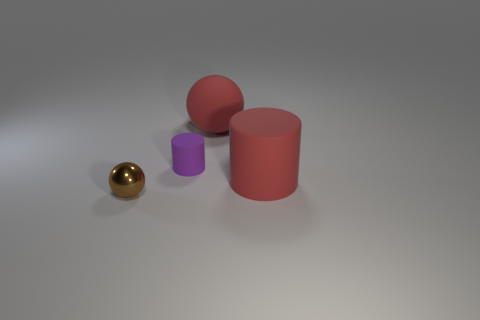Is the material of the red thing in front of the purple object the same as the small purple thing?
Ensure brevity in your answer.  Yes. What material is the brown ball that is the same size as the purple matte cylinder?
Your response must be concise. Metal. How many other objects are there of the same material as the small purple object?
Give a very brief answer. 2. Do the red matte sphere and the cylinder to the left of the red ball have the same size?
Ensure brevity in your answer.  No. Is the number of tiny brown objects that are to the right of the metal sphere less than the number of cylinders on the right side of the small purple matte thing?
Provide a short and direct response. Yes. What is the size of the cylinder behind the red cylinder?
Your answer should be very brief. Small. Does the brown thing have the same size as the red sphere?
Offer a very short reply. No. What number of things are both on the left side of the rubber sphere and on the right side of the metal object?
Make the answer very short. 1. How many red objects are large metallic objects or tiny cylinders?
Your answer should be very brief. 0. What number of matte objects are red spheres or purple objects?
Keep it short and to the point. 2. 